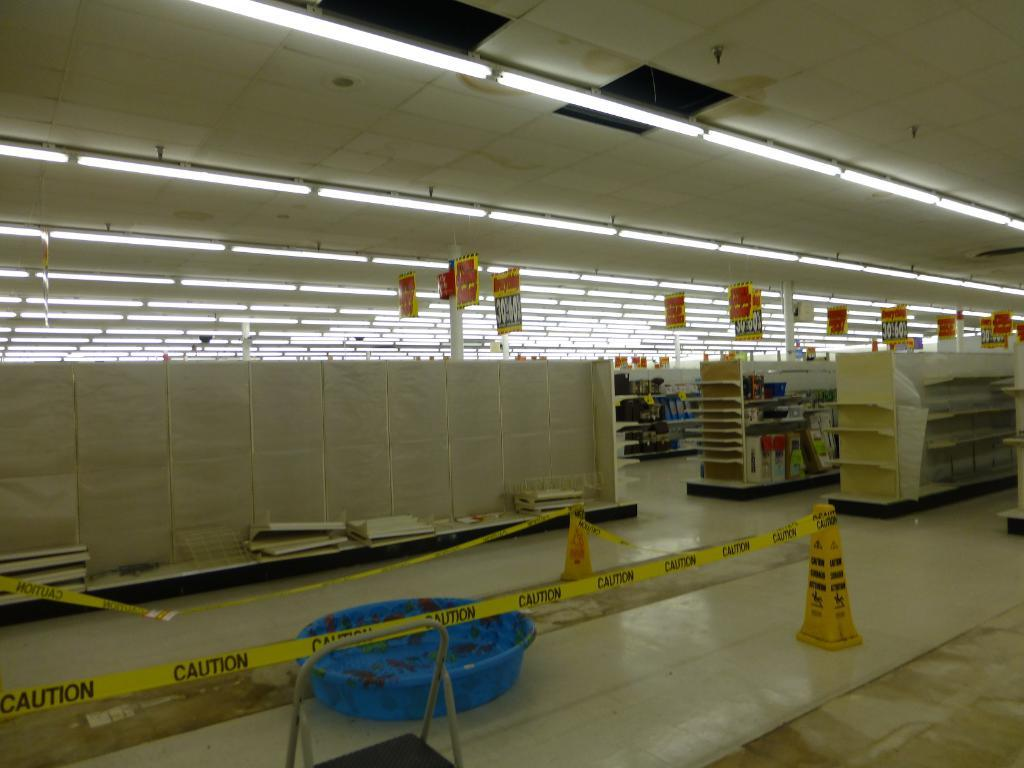Where was the image taken? The image was taken in a building. What can be seen in the image besides the building? There is a ladder, other objects, shelves on the right side, banners at the top, and lights at the top in the image. Can you see a rabbit holding a bomb in the image? No, there is no rabbit or bomb present in the image. Is there any indication of a birth taking place in the image? No, there is no indication of a birth or any related activity in the image. 